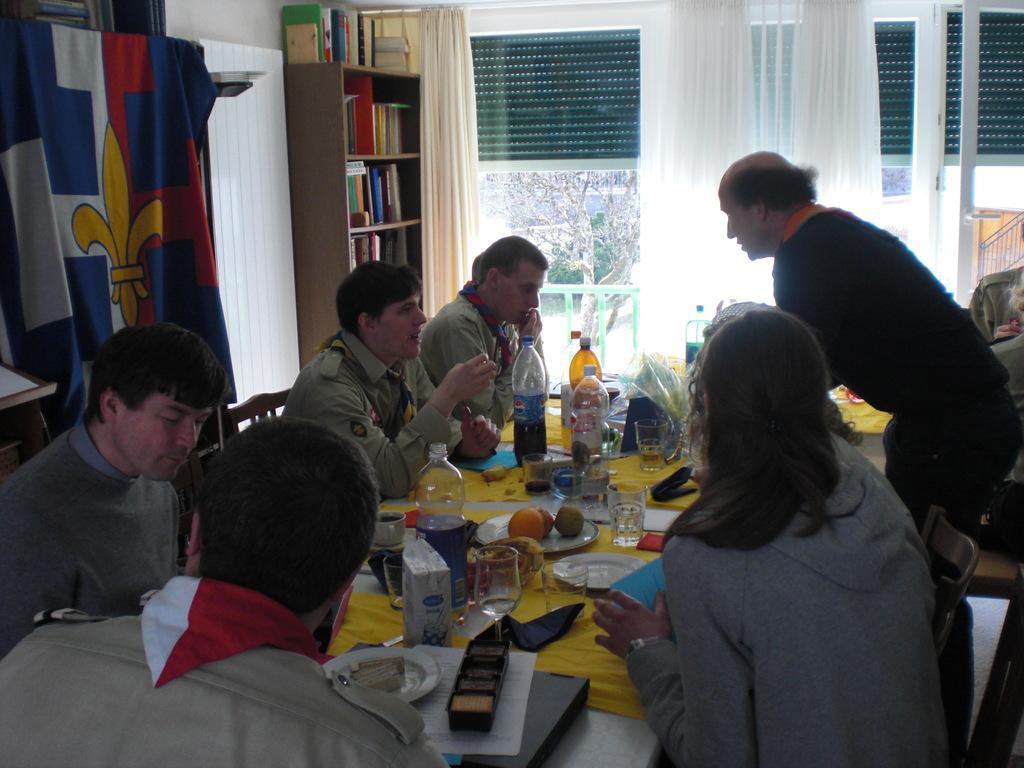Can you describe this image briefly? In this picture we can see a group of people sitting on a chair and dining, here are some water bottle and glasses, and fruits and plates, and some other objects on the table, and right to opposite here is the curtain ,and a window glass and at back, there are trees, and at opposite there are books in the shelves. 